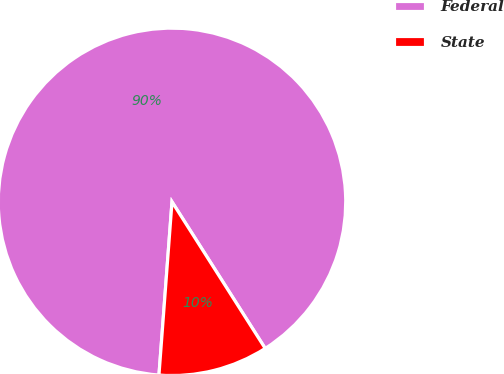Convert chart. <chart><loc_0><loc_0><loc_500><loc_500><pie_chart><fcel>Federal<fcel>State<nl><fcel>89.79%<fcel>10.21%<nl></chart> 